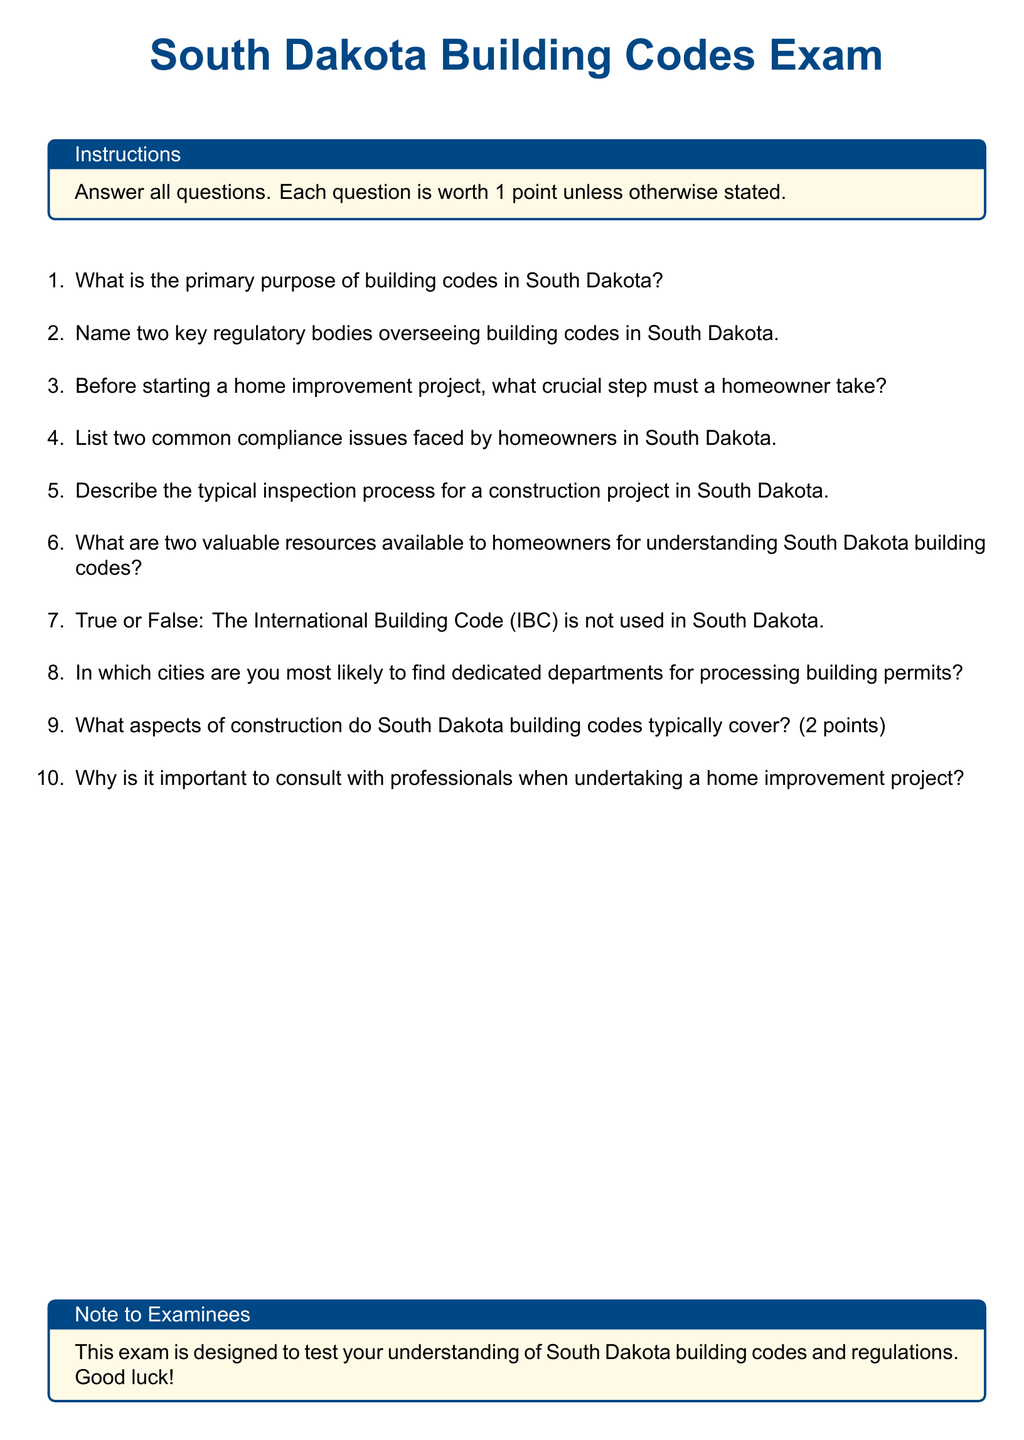What is the primary purpose of building codes in South Dakota? The primary purpose of building codes is to ensure safety, health, and welfare in construction and building projects.
Answer: Safety, health, and welfare Name two key regulatory bodies overseeing building codes in South Dakota. The document implies the need to know the regulatory bodies but does not specify them, so this requires inclusion of knowledge that typically includes the State Department and local authorities.
Answer: State Department, local authorities Before starting a home improvement project, what crucial step must a homeowner take? The crucial step before starting a project is obtaining the necessary building permits.
Answer: Obtain permits List two common compliance issues faced by homeowners in South Dakota. The common compliance issues often involve zoning violations and building code non-compliance.
Answer: Zoning violations, building code non-compliance Describe the typical inspection process for a construction project in South Dakota. The inspection process usually involves multiple stages, including rough, framing, and final inspections to ensure compliance with building codes.
Answer: Multiple stages of inspections What are two valuable resources available to homeowners for understanding South Dakota building codes? Valuable resources can include official government websites and local construction industry associations.
Answer: Government websites, construction industry associations True or False: The International Building Code (IBC) is not used in South Dakota. The question asks to assess the accuracy of the statement based on the information that the IBC is often a basis for state codes.
Answer: False In which cities are you most likely to find dedicated departments for processing building permits? Major cities typically include Sioux Falls and Rapid City as the primary locations for such departments.
Answer: Sioux Falls, Rapid City What aspects of construction do South Dakota building codes typically cover? Building codes typically cover structural integrity, electrical systems, plumbing, and fire safety requirements.
Answer: Structural integrity, electrical systems, plumbing, fire safety Why is it important to consult with professionals when undertaking a home improvement project? Consulting with professionals ensures compliance with codes and helps avoid costly mistakes during the project.
Answer: Ensure compliance, avoid mistakes 